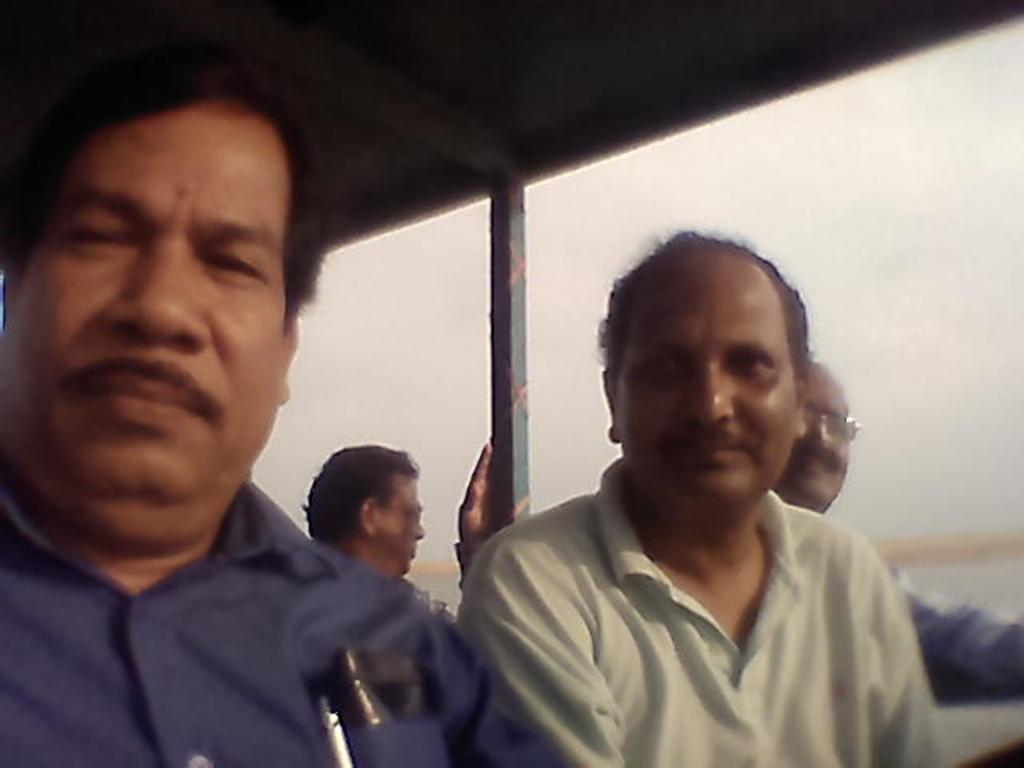How many people are in the front of the image? There are four men in the front of the image. What can be seen on the right side of the image? There appears to be water on the right side of the image. What is visible in the background of the image? The sky is visible in the background of the image. What type of sticks can be seen in the image? There are no sticks present in the image. What is the taste of the water in the image? The taste of the water cannot be determined from the image, as taste is not a visual characteristic. 